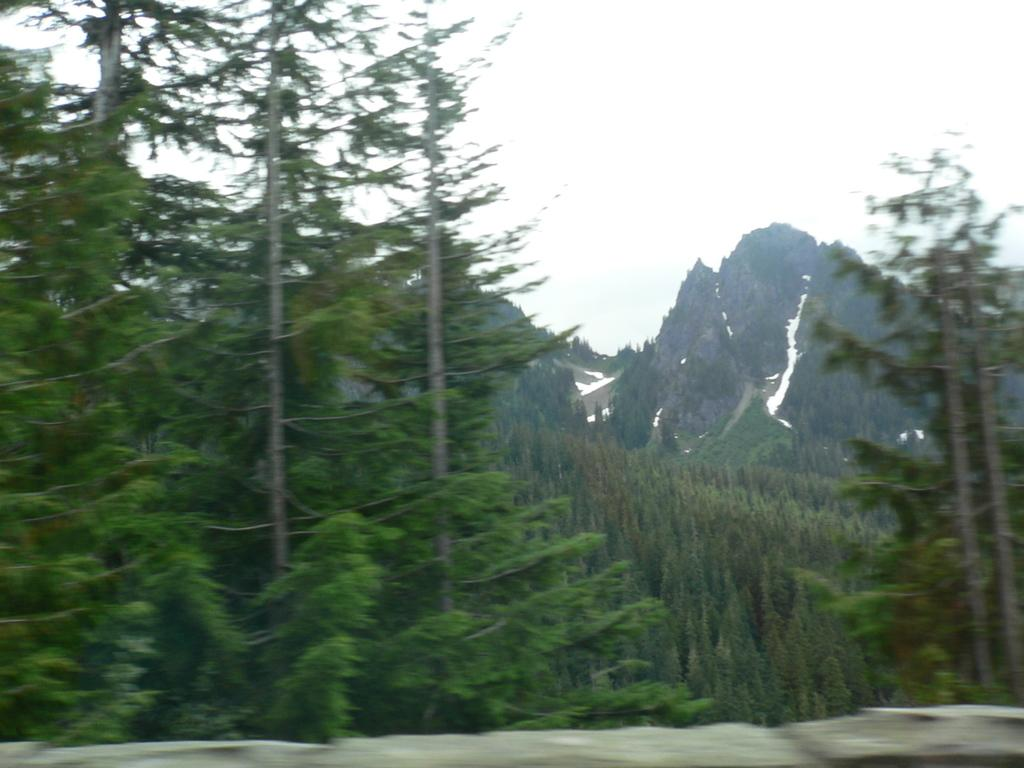What type of vegetation can be seen in the image? There are trees in the image. What can be seen in the distance in the image? There are hills visible in the background of the image. What part of the natural environment is visible in the image? The sky is visible in the background of the image. What type of fruit is the queen holding in the image? There is no queen or fruit present in the image; it only features trees, hills, and the sky. 